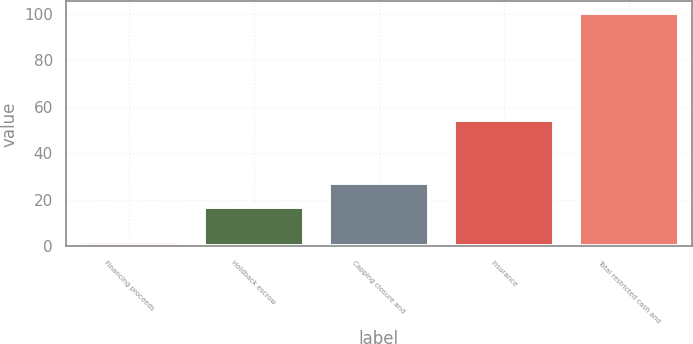Convert chart to OTSL. <chart><loc_0><loc_0><loc_500><loc_500><bar_chart><fcel>Financing proceeds<fcel>Holdback escrow<fcel>Capping closure and<fcel>Insurance<fcel>Total restricted cash and<nl><fcel>2.1<fcel>16.8<fcel>27.3<fcel>54.1<fcel>100.3<nl></chart> 